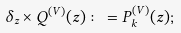Convert formula to latex. <formula><loc_0><loc_0><loc_500><loc_500>\delta _ { z } \times Q ^ { ( V ) } ( z ) \colon = P _ { k } ^ { ( V ) } ( z ) ;</formula> 